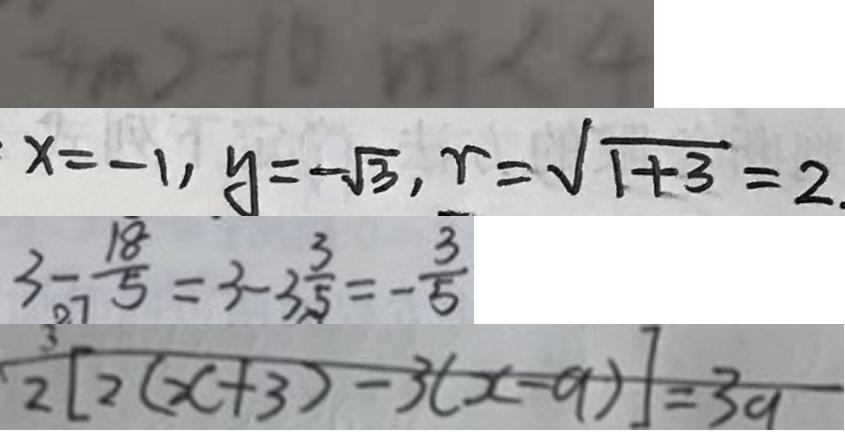Convert formula to latex. <formula><loc_0><loc_0><loc_500><loc_500>- 4 m > - 1 6 m < 4 
 x = - 1 , y = - \sqrt { 3 } , r = \sqrt { 1 + 3 } = 2 . 
 3 - \frac { 1 8 } { 5 } = 3 - 3 \frac { 3 } { 5 } = - \frac { 3 } { 5 } 
 2 [ 2 ( x + 3 ) - 3 ( x - 9 ) ] = 3 9</formula> 